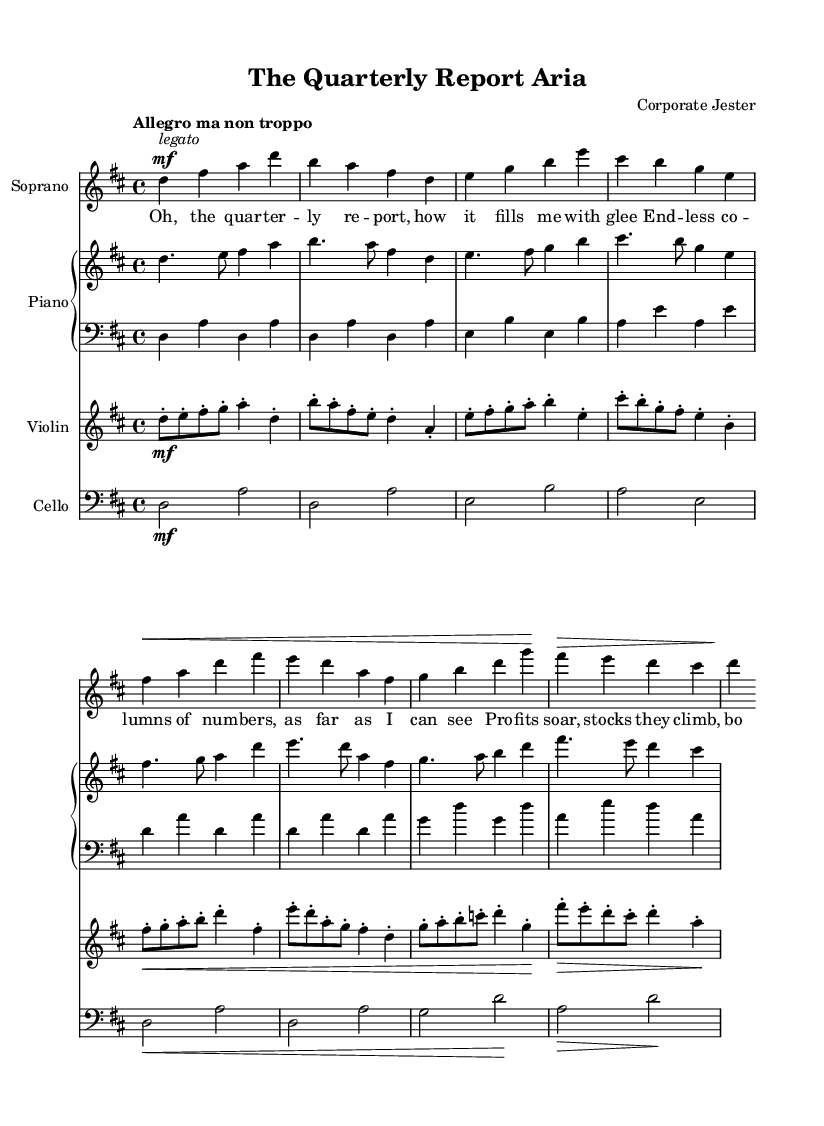What is the key signature of this music? The key signature is indicated by the number of sharps or flats at the beginning of the staff. In this sheet music, there are two sharps (F# and C#), which corresponds to D major.
Answer: D major What is the time signature of this music? The time signature is represented after the clef and key signature. Here, it is indicated as 4/4, which means there are four beats in a measure and the quarter note gets one beat.
Answer: 4/4 What is the tempo marking for this piece? The tempo marking is shown at the beginning of the score. Here, it is "Allegro ma non troppo," which suggests a lively tempo but not overly fast.
Answer: Allegro ma non troppo Which instrument is featured as the solo voice? The title and dedicated staff indicate that the Soprano section is the solo voice part.
Answer: Soprano How many measures are in the soprano voice part? By counting each individual bar line (the vertical lines that divide the music), we can see there are a total of 8 measures in the soprano voice part.
Answer: 8 What dynamic marking is indicated for the soprano voice at the beginning? The dynamic marking at the beginning is marked as "mf," which stands for mezzo-forte, indicating a moderately loud sound.
Answer: mf What is the relationship between the piano right hand and the left hand in this score? The piano right hand and left hand have separate staves, with the right hand playing higher pitches (treble clef) and the left hand playing lower pitches (bass clef), completing the harmonic texture of the piece.
Answer: Upper and lower 